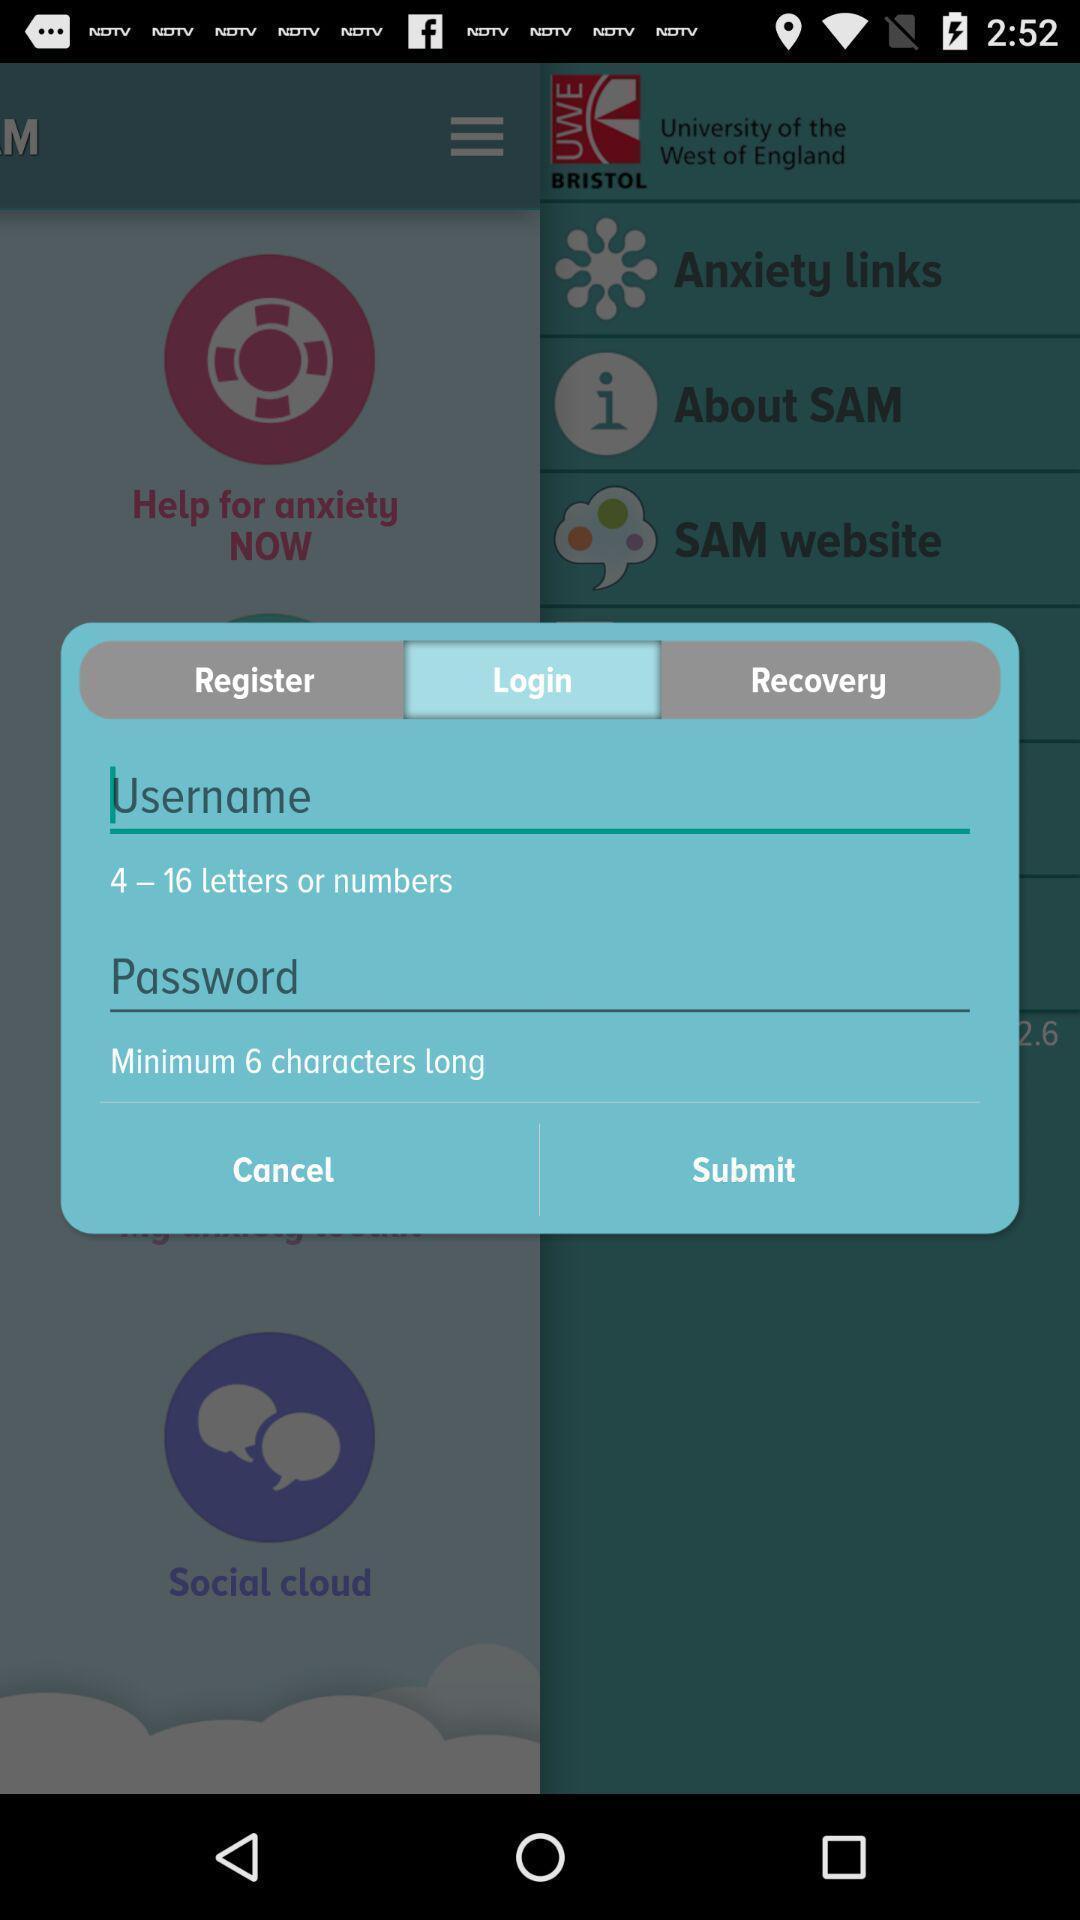Describe the key features of this screenshot. Pop-up shows login page. 